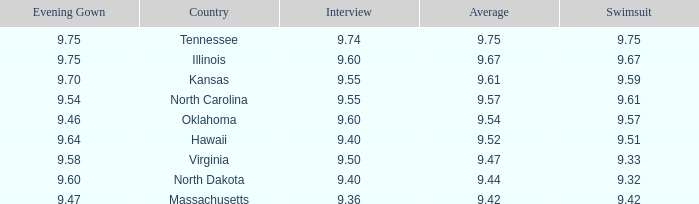What score did hawaii receive in the interview? 9.4. 